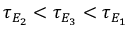Convert formula to latex. <formula><loc_0><loc_0><loc_500><loc_500>\tau _ { E _ { 2 } } < \tau _ { E _ { 3 } } < \tau _ { E _ { 1 } }</formula> 